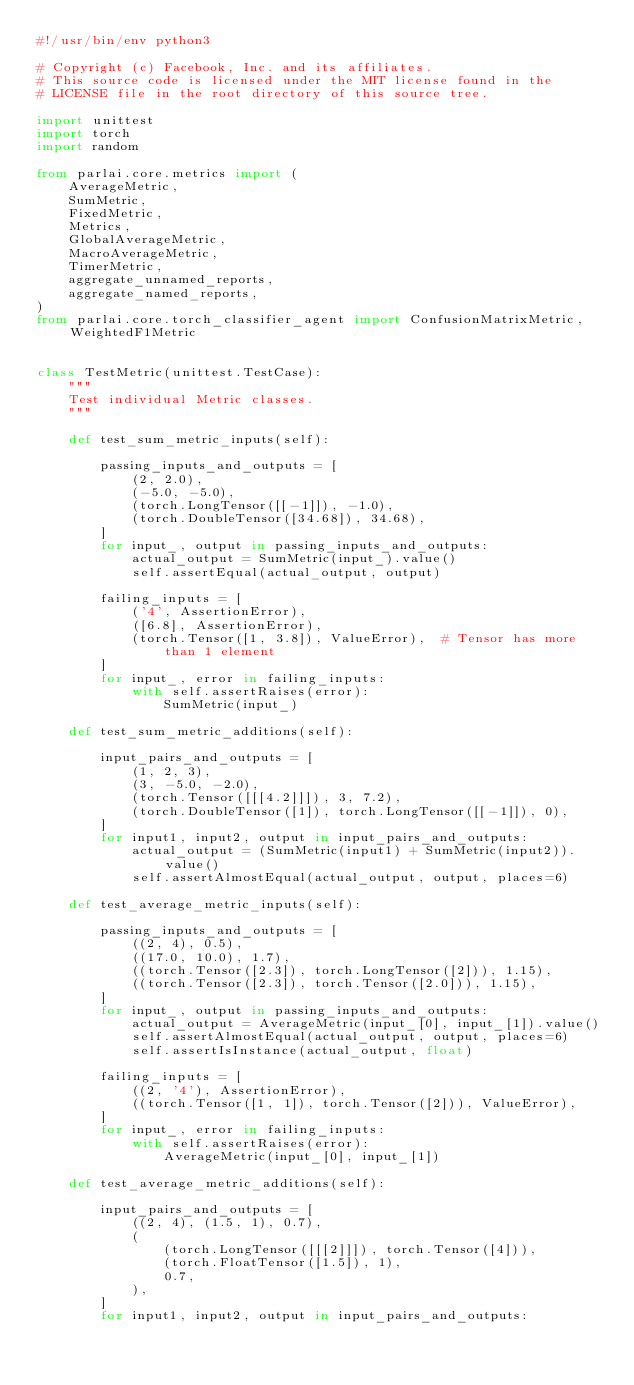Convert code to text. <code><loc_0><loc_0><loc_500><loc_500><_Python_>#!/usr/bin/env python3

# Copyright (c) Facebook, Inc. and its affiliates.
# This source code is licensed under the MIT license found in the
# LICENSE file in the root directory of this source tree.

import unittest
import torch
import random

from parlai.core.metrics import (
    AverageMetric,
    SumMetric,
    FixedMetric,
    Metrics,
    GlobalAverageMetric,
    MacroAverageMetric,
    TimerMetric,
    aggregate_unnamed_reports,
    aggregate_named_reports,
)
from parlai.core.torch_classifier_agent import ConfusionMatrixMetric, WeightedF1Metric


class TestMetric(unittest.TestCase):
    """
    Test individual Metric classes.
    """

    def test_sum_metric_inputs(self):

        passing_inputs_and_outputs = [
            (2, 2.0),
            (-5.0, -5.0),
            (torch.LongTensor([[-1]]), -1.0),
            (torch.DoubleTensor([34.68]), 34.68),
        ]
        for input_, output in passing_inputs_and_outputs:
            actual_output = SumMetric(input_).value()
            self.assertEqual(actual_output, output)

        failing_inputs = [
            ('4', AssertionError),
            ([6.8], AssertionError),
            (torch.Tensor([1, 3.8]), ValueError),  # Tensor has more than 1 element
        ]
        for input_, error in failing_inputs:
            with self.assertRaises(error):
                SumMetric(input_)

    def test_sum_metric_additions(self):

        input_pairs_and_outputs = [
            (1, 2, 3),
            (3, -5.0, -2.0),
            (torch.Tensor([[[4.2]]]), 3, 7.2),
            (torch.DoubleTensor([1]), torch.LongTensor([[-1]]), 0),
        ]
        for input1, input2, output in input_pairs_and_outputs:
            actual_output = (SumMetric(input1) + SumMetric(input2)).value()
            self.assertAlmostEqual(actual_output, output, places=6)

    def test_average_metric_inputs(self):

        passing_inputs_and_outputs = [
            ((2, 4), 0.5),
            ((17.0, 10.0), 1.7),
            ((torch.Tensor([2.3]), torch.LongTensor([2])), 1.15),
            ((torch.Tensor([2.3]), torch.Tensor([2.0])), 1.15),
        ]
        for input_, output in passing_inputs_and_outputs:
            actual_output = AverageMetric(input_[0], input_[1]).value()
            self.assertAlmostEqual(actual_output, output, places=6)
            self.assertIsInstance(actual_output, float)

        failing_inputs = [
            ((2, '4'), AssertionError),
            ((torch.Tensor([1, 1]), torch.Tensor([2])), ValueError),
        ]
        for input_, error in failing_inputs:
            with self.assertRaises(error):
                AverageMetric(input_[0], input_[1])

    def test_average_metric_additions(self):

        input_pairs_and_outputs = [
            ((2, 4), (1.5, 1), 0.7),
            (
                (torch.LongTensor([[[2]]]), torch.Tensor([4])),
                (torch.FloatTensor([1.5]), 1),
                0.7,
            ),
        ]
        for input1, input2, output in input_pairs_and_outputs:</code> 